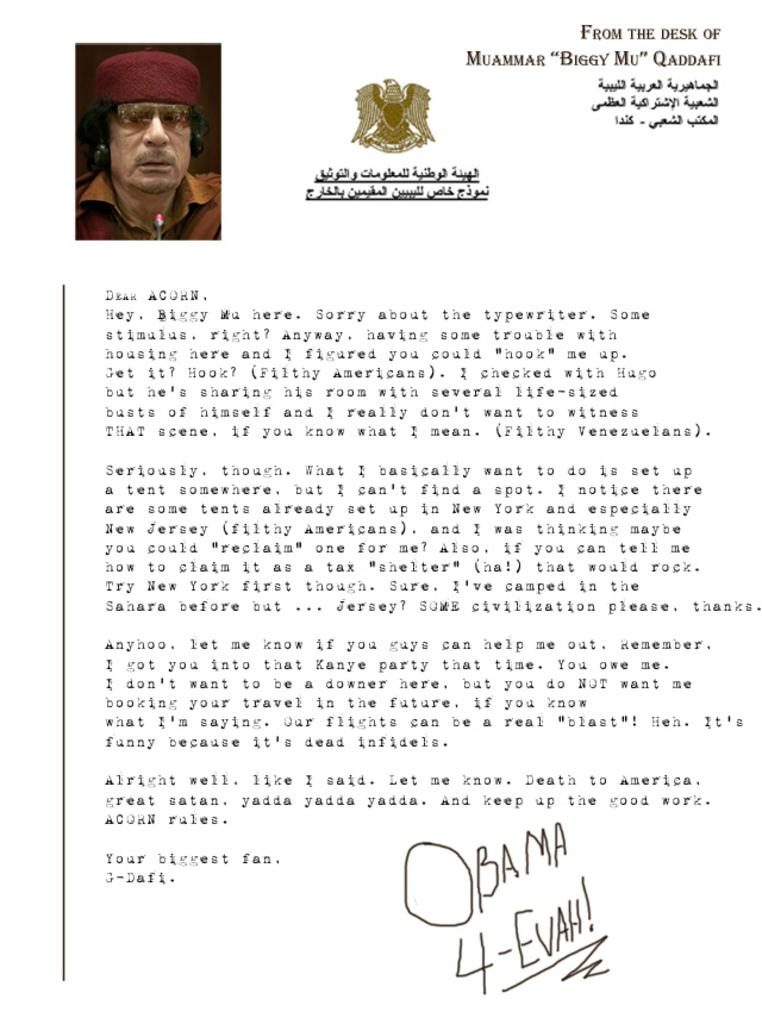What is the main subject of the image? There is a photograph of a person in the image. What else can be seen in the image besides the person? There is text and a logo in the image. How many trees are visible in the image? There are no trees visible in the image. What type of operation is being performed in the image? There is no operation or activity depicted in the image. 